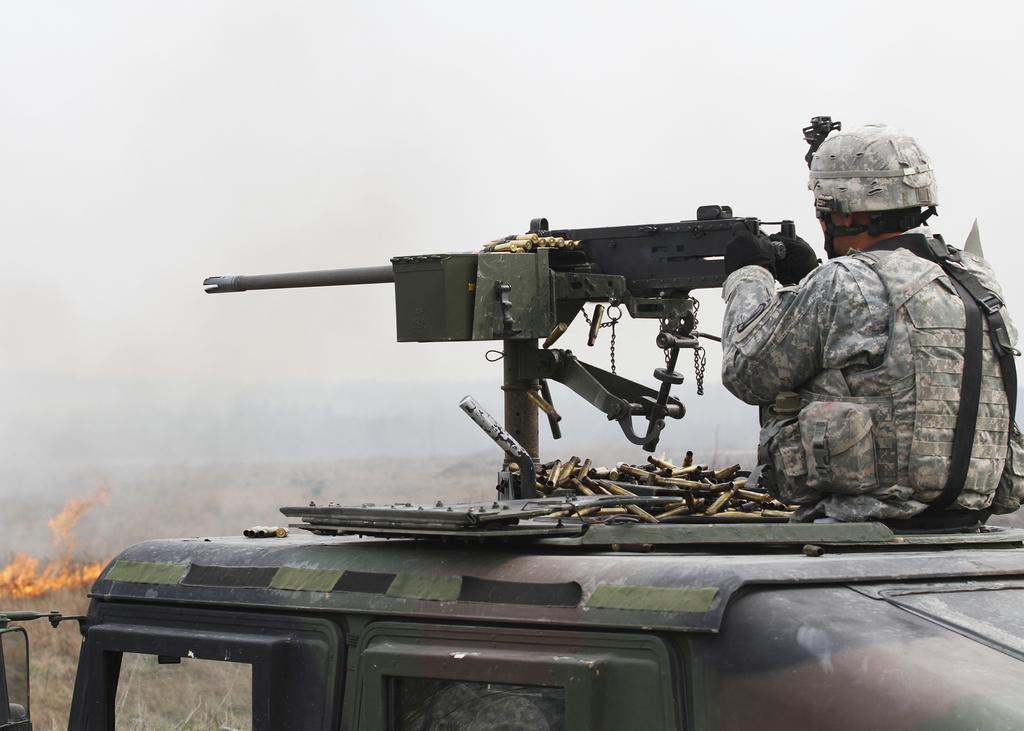How would you summarize this image in a sentence or two? In the picture we can see a army vehicle on the top of it we can see a army man holding and gun and firing and near to the gun we can see many bullets on the vehicle and in the background we can see fire. 